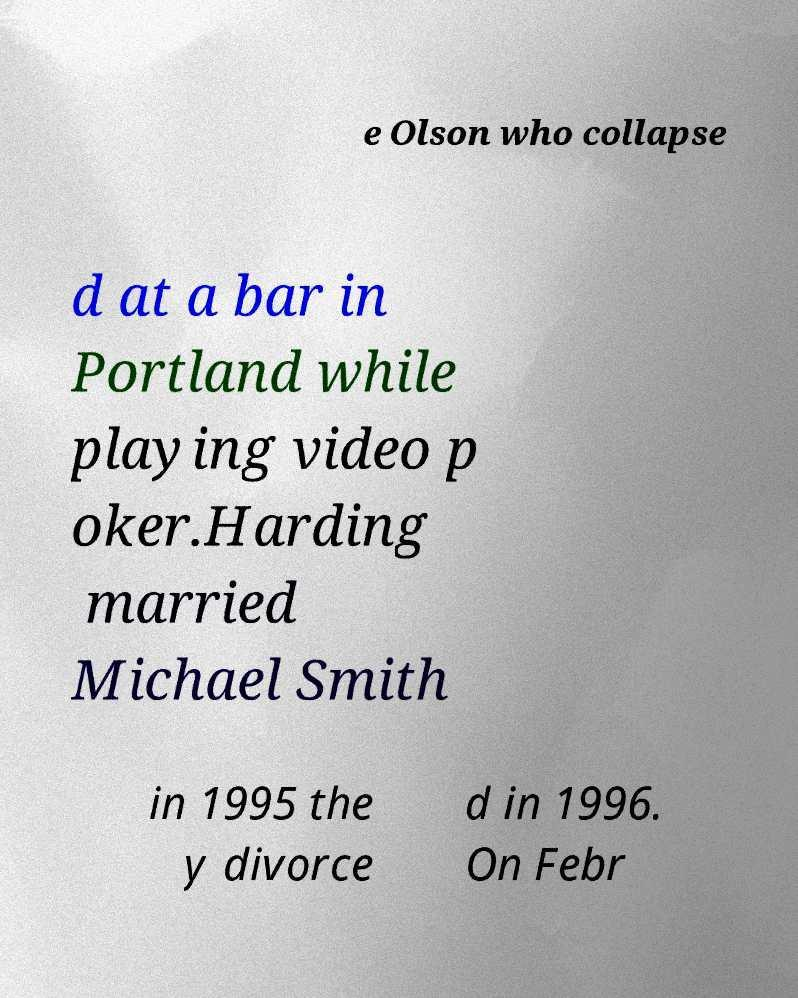Please read and relay the text visible in this image. What does it say? e Olson who collapse d at a bar in Portland while playing video p oker.Harding married Michael Smith in 1995 the y divorce d in 1996. On Febr 